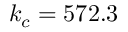<formula> <loc_0><loc_0><loc_500><loc_500>k _ { c } = 5 7 2 . 3</formula> 